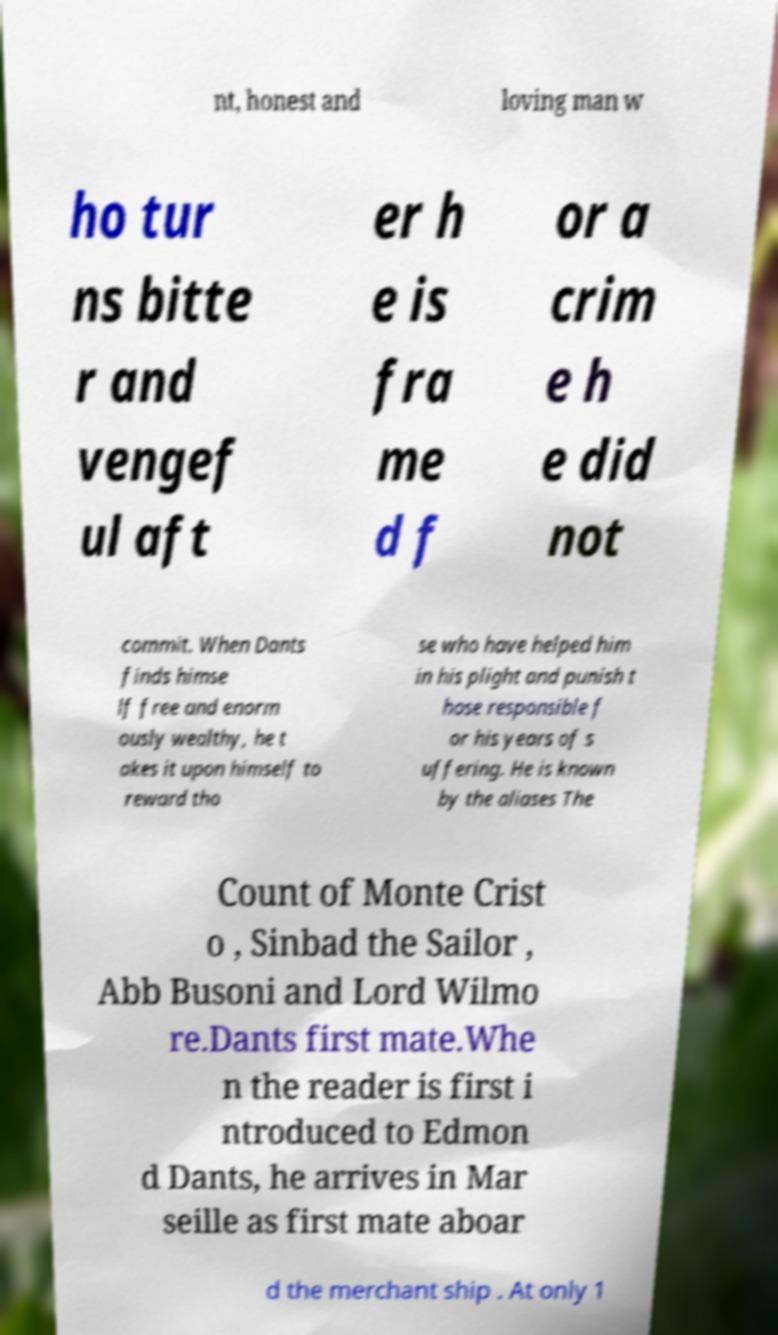Could you assist in decoding the text presented in this image and type it out clearly? nt, honest and loving man w ho tur ns bitte r and vengef ul aft er h e is fra me d f or a crim e h e did not commit. When Dants finds himse lf free and enorm ously wealthy, he t akes it upon himself to reward tho se who have helped him in his plight and punish t hose responsible f or his years of s uffering. He is known by the aliases The Count of Monte Crist o , Sinbad the Sailor , Abb Busoni and Lord Wilmo re.Dants first mate.Whe n the reader is first i ntroduced to Edmon d Dants, he arrives in Mar seille as first mate aboar d the merchant ship . At only 1 